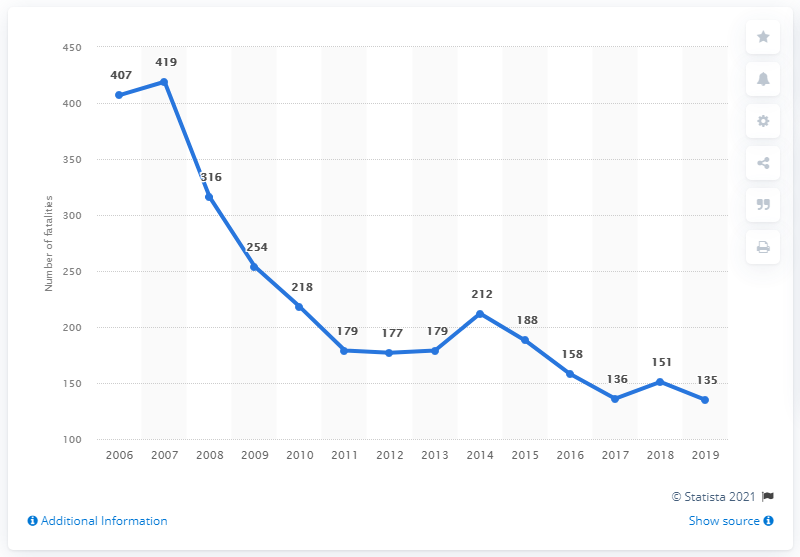How many road fatalities occurred in Latvia between 2006 and 2019? Between 2006 and 2019, the total number of road fatalities in Latvia was 3,287, as calculated by summing the yearly data provided in the graph. This period observed a general downward trend in road fatalities, indicating increased road safety measures or improvements in vehicle safety. 